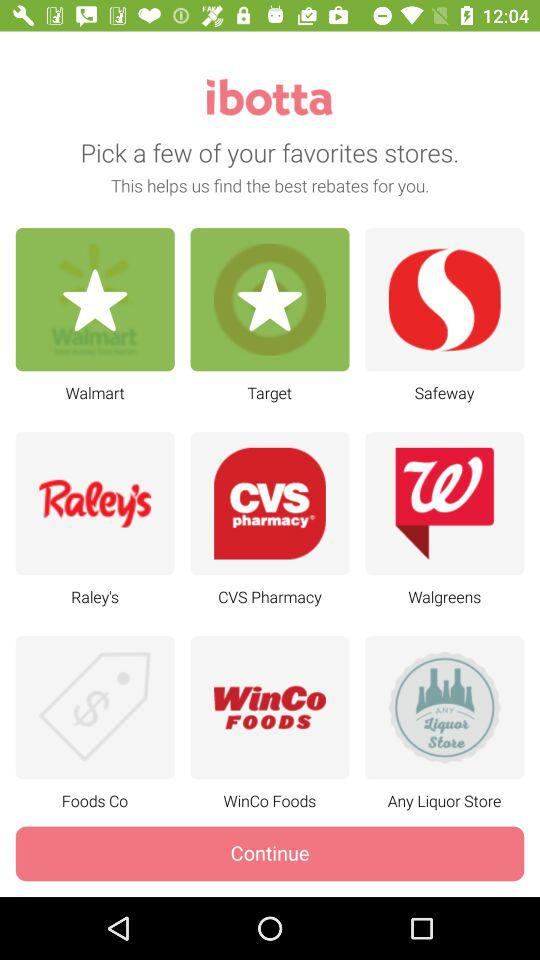What are the different available store options? The different available store options are "Walmart", "Target", "Safeway", "Raley's", "CVS Pharmacy", "Walgreens", "Foods Co", "WinCo Foods" and "Any Liquor Store". 